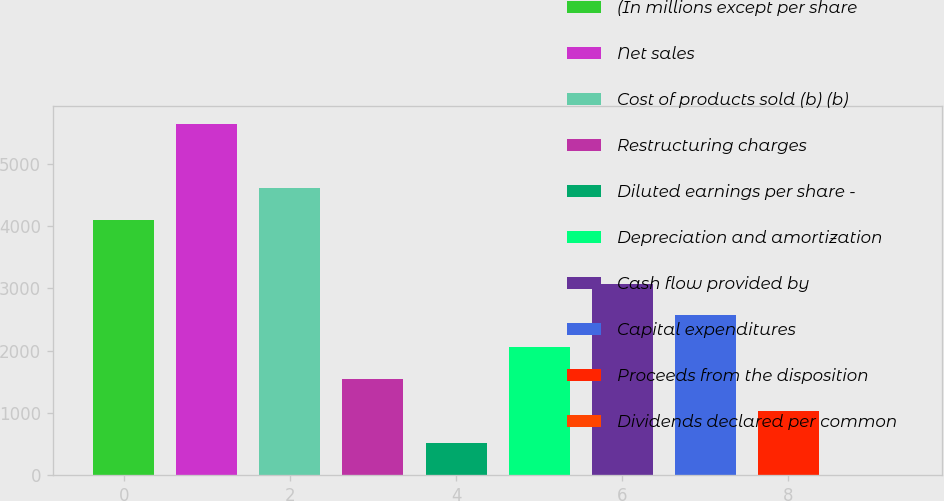<chart> <loc_0><loc_0><loc_500><loc_500><bar_chart><fcel>(In millions except per share<fcel>Net sales<fcel>Cost of products sold (b) (b)<fcel>Restructuring charges<fcel>Diluted earnings per share -<fcel>Depreciation and amortization<fcel>Cash flow provided by<fcel>Capital expenditures<fcel>Proceeds from the disposition<fcel>Dividends declared per common<nl><fcel>4102.9<fcel>5641.24<fcel>4615.68<fcel>1539<fcel>513.44<fcel>2051.78<fcel>3077.34<fcel>2564.56<fcel>1026.22<fcel>0.66<nl></chart> 